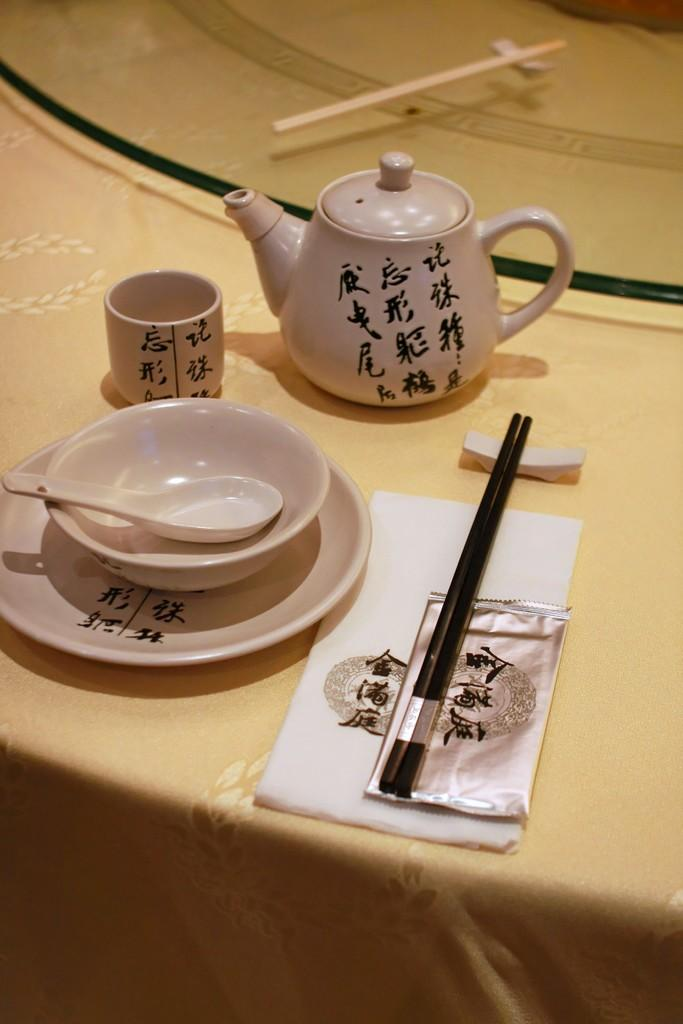What type of dishware is present on the table in the image? There is a cup, a bowl, a spoon, a plate, chopsticks, and a teapot on the table in the image. What might be used for eating or drinking in the image? The spoon, chopsticks, and cup could be used for eating or drinking in the image. What is the purpose of the teapot in the image? The teapot is likely used for serving or holding hot beverages in the image. Can you tell me how many snails are crawling on the table in the image? There are no snails present on the table in the image. What type of game is being played on the table in the image? There is no game, such as chess, present on the table in the image. 